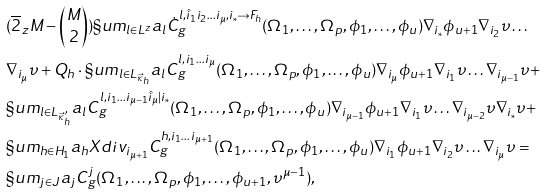<formula> <loc_0><loc_0><loc_500><loc_500>& ( \overline { 2 } _ { z } M - { { M } \choose { 2 } } ) \S u m _ { l \in L ^ { z } } a _ { l } \dot { C } ^ { l , \hat { i } _ { 1 } i _ { 2 } \dots i _ { \mu } , i _ { * } \rightarrow F _ { h } } _ { g } ( \Omega _ { 1 } , \dots , \Omega _ { p } , \phi _ { 1 } , \dots , \phi _ { u } ) \nabla _ { i _ { * } } \phi _ { u + 1 } \nabla _ { i _ { 2 } } \upsilon \dots \\ & \nabla _ { i _ { \mu } } \upsilon + Q _ { h } \cdot \S u m _ { l \in L _ { \vec { \kappa } _ { h } } } a _ { l } C ^ { l , i _ { 1 } \dots i _ { \mu } } _ { g } ( \Omega _ { 1 } , \dots , \Omega _ { p } , \phi _ { 1 } , \dots , \phi _ { u } ) \nabla _ { i _ { \mu } } \phi _ { u + 1 } \nabla _ { i _ { 1 } } \upsilon \dots \nabla _ { i _ { \mu - 1 } } \upsilon + \\ & \S u m _ { l \in L _ { \vec { \kappa } ^ { \prime } _ { h } } } a _ { l } C ^ { l , i _ { 1 } \dots i _ { \mu - 1 } \hat { i } _ { \mu } | i _ { * } } _ { g } ( \Omega _ { 1 } , \dots , \Omega _ { p } , \phi _ { 1 } , \dots , \phi _ { u } ) \nabla _ { i _ { \mu - 1 } } \phi _ { u + 1 } \nabla _ { i _ { 1 } } \upsilon \dots \nabla _ { i _ { \mu - 2 } } \upsilon \nabla _ { i _ { * } } \upsilon + \\ & \S u m _ { h \in H _ { 1 } } a _ { h } X d i v _ { i _ { \mu + 1 } } C ^ { h , i _ { 1 } \dots i _ { \mu + 1 } } _ { g } ( \Omega _ { 1 } , \dots , \Omega _ { p } , \phi _ { 1 } , \dots , \phi _ { u } ) \nabla _ { i _ { 1 } } \phi _ { u + 1 } \nabla _ { i _ { 2 } } \upsilon \dots \nabla _ { i _ { \mu } } \upsilon = \\ & \S u m _ { j \in J } a _ { j } C ^ { j } _ { g } ( \Omega _ { 1 } , \dots , \Omega _ { p } , \phi _ { 1 } , \dots , \phi _ { u + 1 } , \upsilon ^ { \mu - 1 } ) ,</formula> 